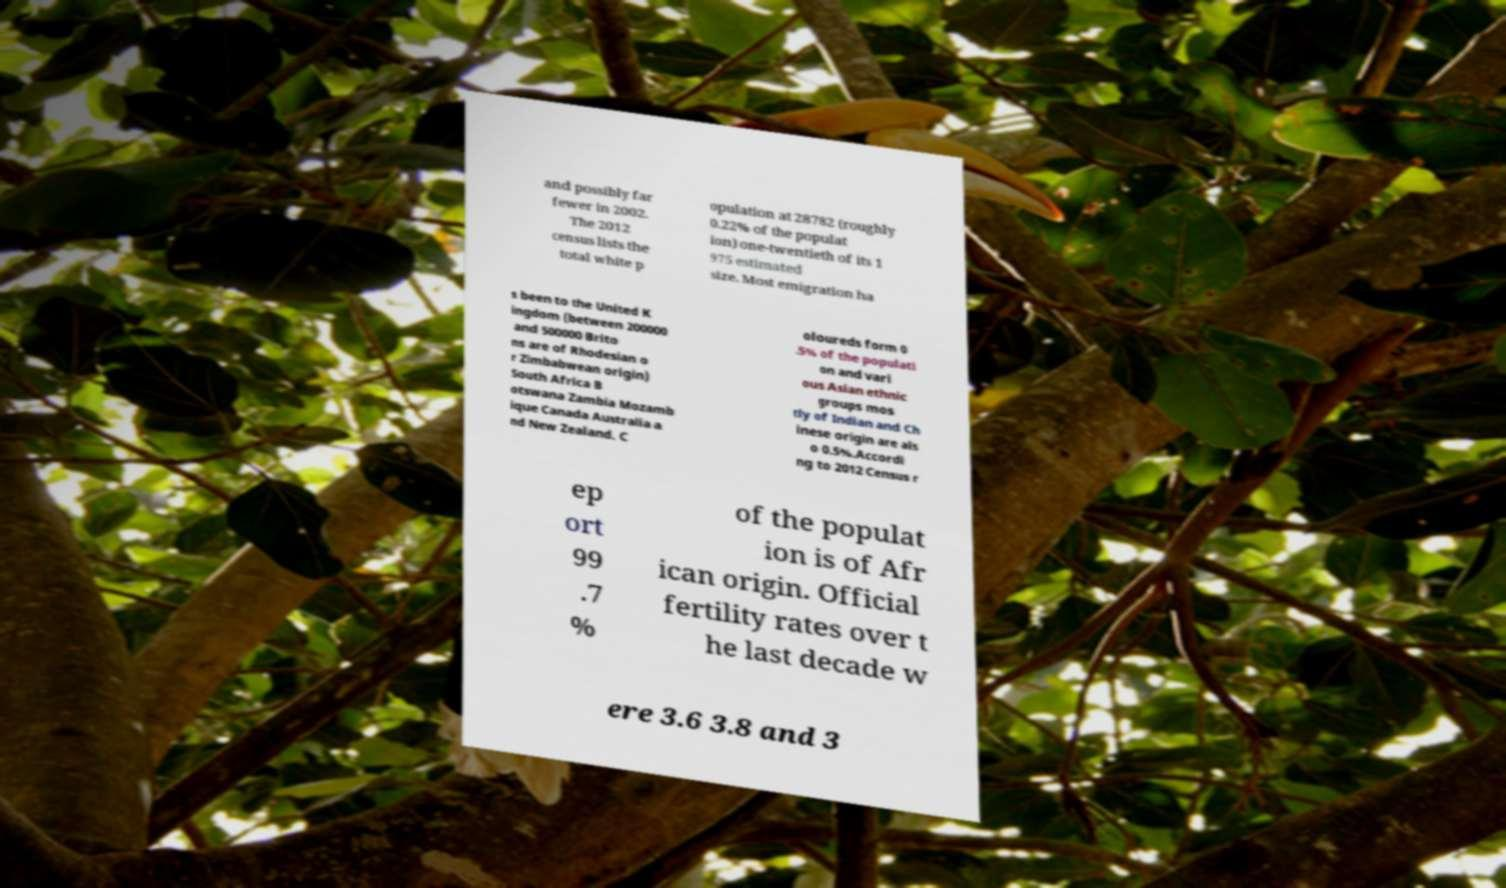Could you assist in decoding the text presented in this image and type it out clearly? and possibly far fewer in 2002. The 2012 census lists the total white p opulation at 28782 (roughly 0.22% of the populat ion) one-twentieth of its 1 975 estimated size. Most emigration ha s been to the United K ingdom (between 200000 and 500000 Brito ns are of Rhodesian o r Zimbabwean origin) South Africa B otswana Zambia Mozamb ique Canada Australia a nd New Zealand. C oloureds form 0 .5% of the populati on and vari ous Asian ethnic groups mos tly of Indian and Ch inese origin are als o 0.5%.Accordi ng to 2012 Census r ep ort 99 .7 % of the populat ion is of Afr ican origin. Official fertility rates over t he last decade w ere 3.6 3.8 and 3 